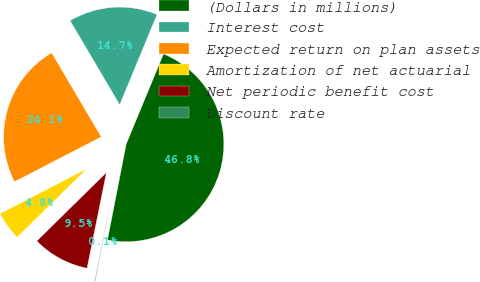Convert chart to OTSL. <chart><loc_0><loc_0><loc_500><loc_500><pie_chart><fcel>(Dollars in millions)<fcel>Interest cost<fcel>Expected return on plan assets<fcel>Amortization of net actuarial<fcel>Net periodic benefit cost<fcel>Discount rate<nl><fcel>46.83%<fcel>14.73%<fcel>24.11%<fcel>4.78%<fcel>9.45%<fcel>0.1%<nl></chart> 